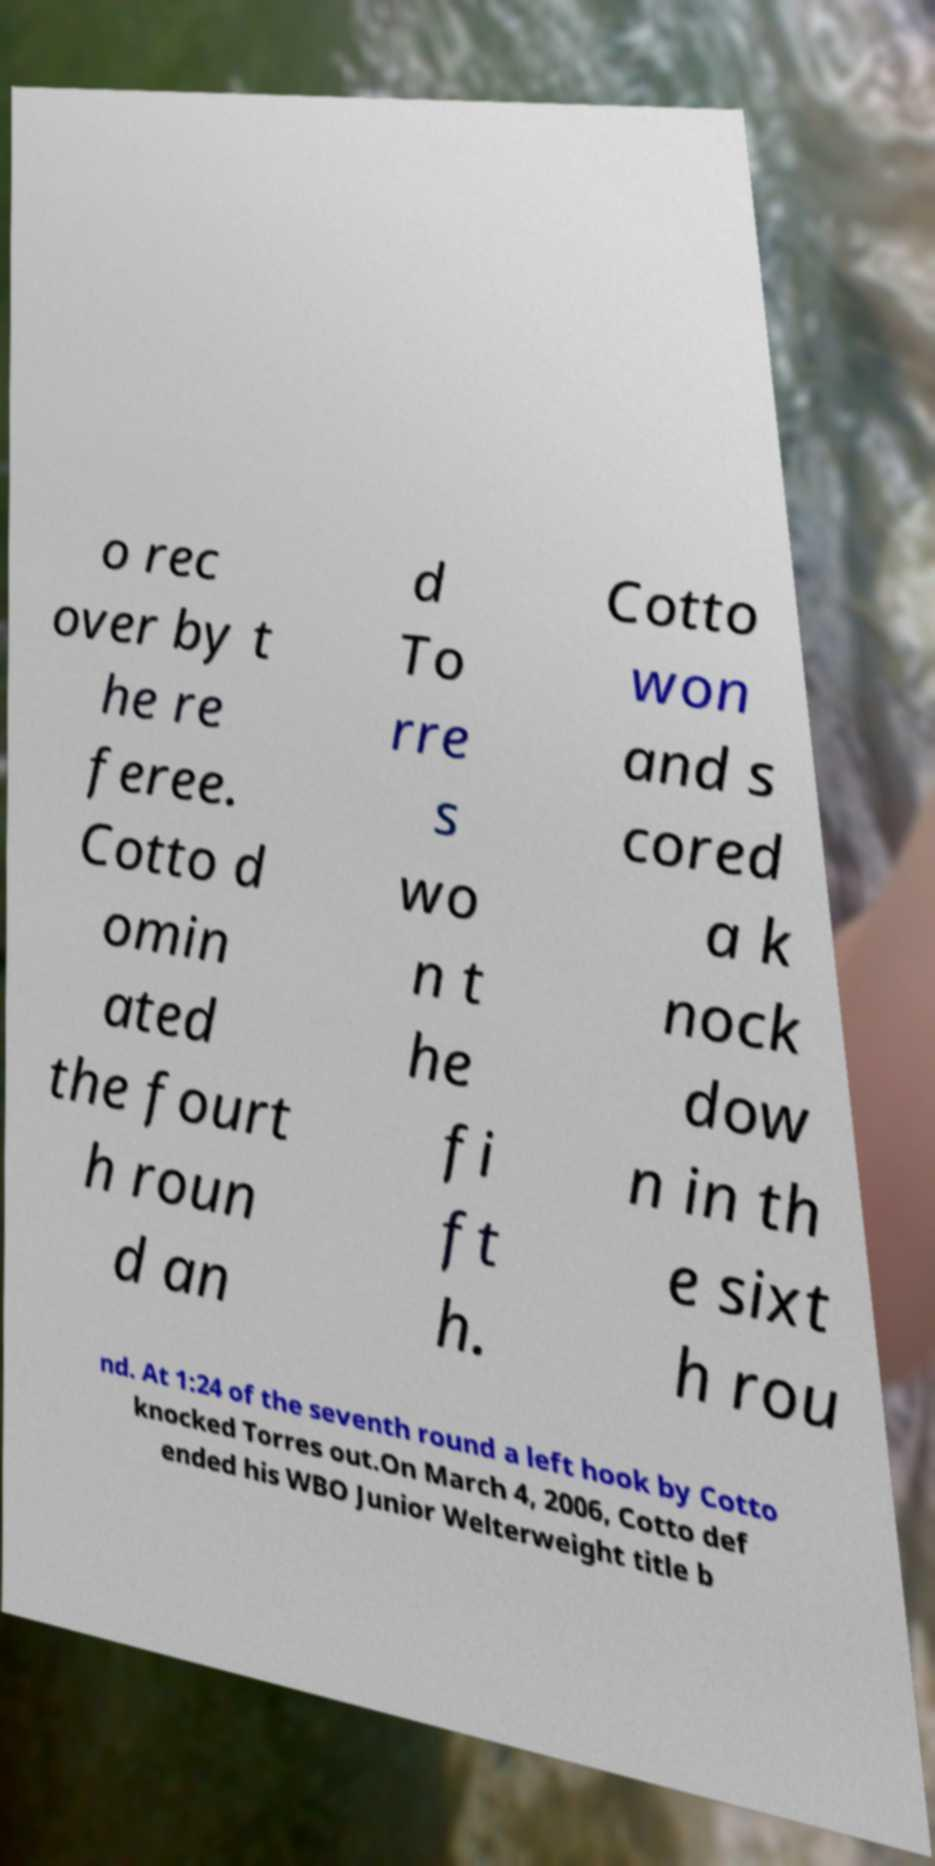Please read and relay the text visible in this image. What does it say? o rec over by t he re feree. Cotto d omin ated the fourt h roun d an d To rre s wo n t he fi ft h. Cotto won and s cored a k nock dow n in th e sixt h rou nd. At 1:24 of the seventh round a left hook by Cotto knocked Torres out.On March 4, 2006, Cotto def ended his WBO Junior Welterweight title b 